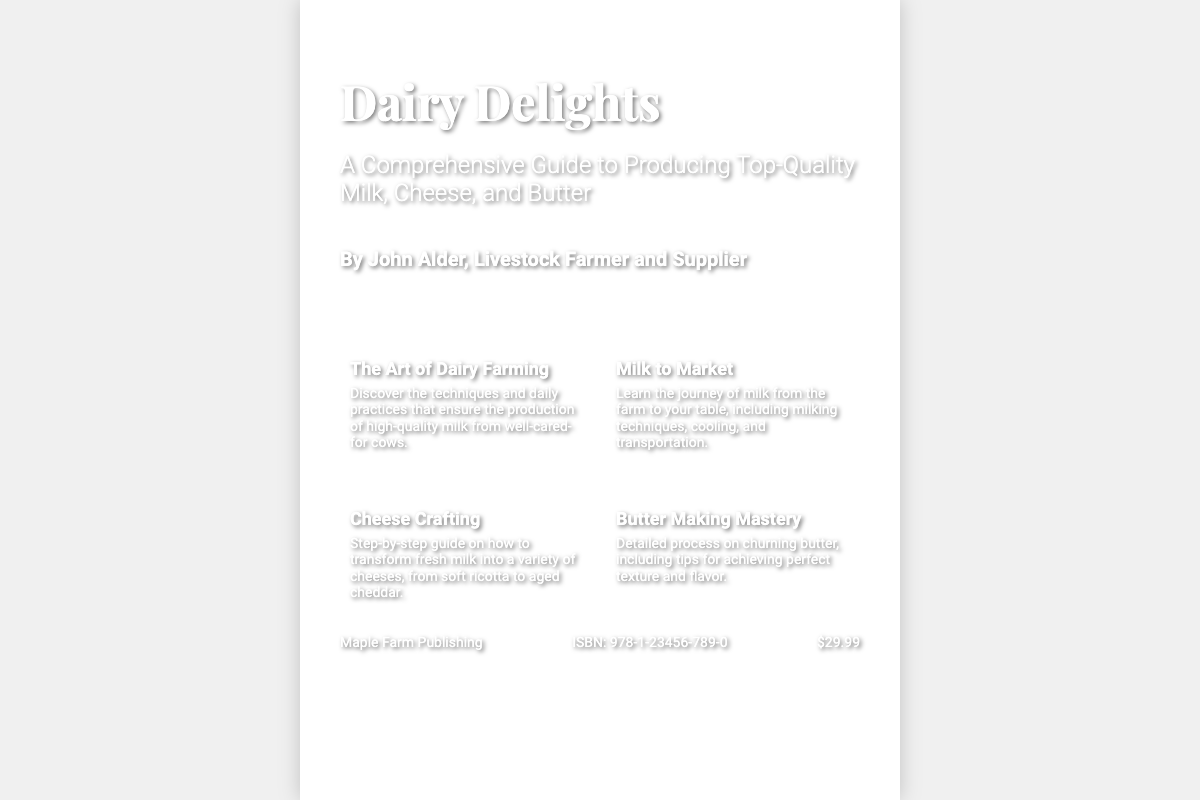What is the title of the book? The title can be found prominently displayed at the top of the book cover.
Answer: Dairy Delights Who is the author of the book? The author's name is listed below the subtitle on the cover.
Answer: John Alder What is the price of the book? The price is displayed in the footer section of the cover.
Answer: $29.99 What type of guide is this book? The subtitle describes the focus of the book as a comprehensive guide.
Answer: Comprehensive Guide How many key elements are mentioned on the cover? The number of key elements is identifiable in the layout of the content section.
Answer: Four What is the ISBN of the book? The ISBN is located in the footer of the book cover.
Answer: 978-1-23456-789-0 What farm product is emphasized in the crafting guide? The crafting guide specifically focuses on a product detailed in one of the key elements.
Answer: Cheese What is one of the techniques mentioned for dairy farming? The description under the first key element refers to techniques used for dairy farming.
Answer: Daily practices What publishing company released this book? The publisher's name is mentioned at the bottom of the cover.
Answer: Maple Farm Publishing 